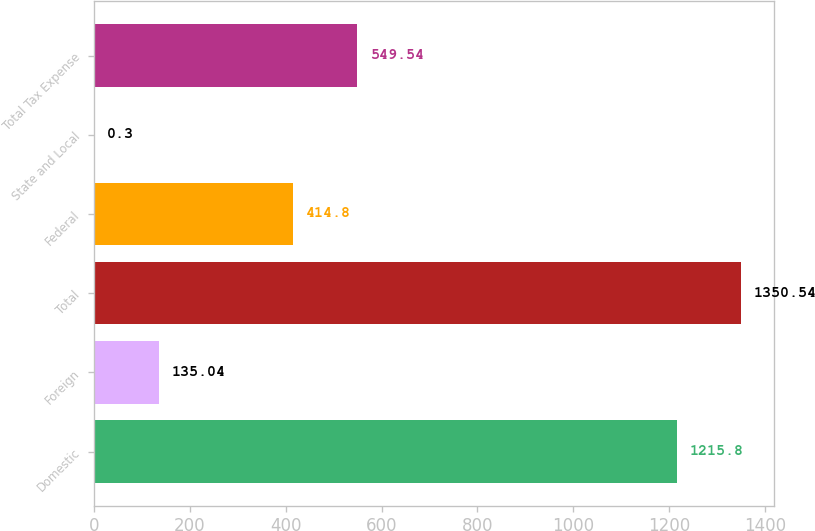Convert chart to OTSL. <chart><loc_0><loc_0><loc_500><loc_500><bar_chart><fcel>Domestic<fcel>Foreign<fcel>Total<fcel>Federal<fcel>State and Local<fcel>Total Tax Expense<nl><fcel>1215.8<fcel>135.04<fcel>1350.54<fcel>414.8<fcel>0.3<fcel>549.54<nl></chart> 